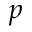<formula> <loc_0><loc_0><loc_500><loc_500>p</formula> 